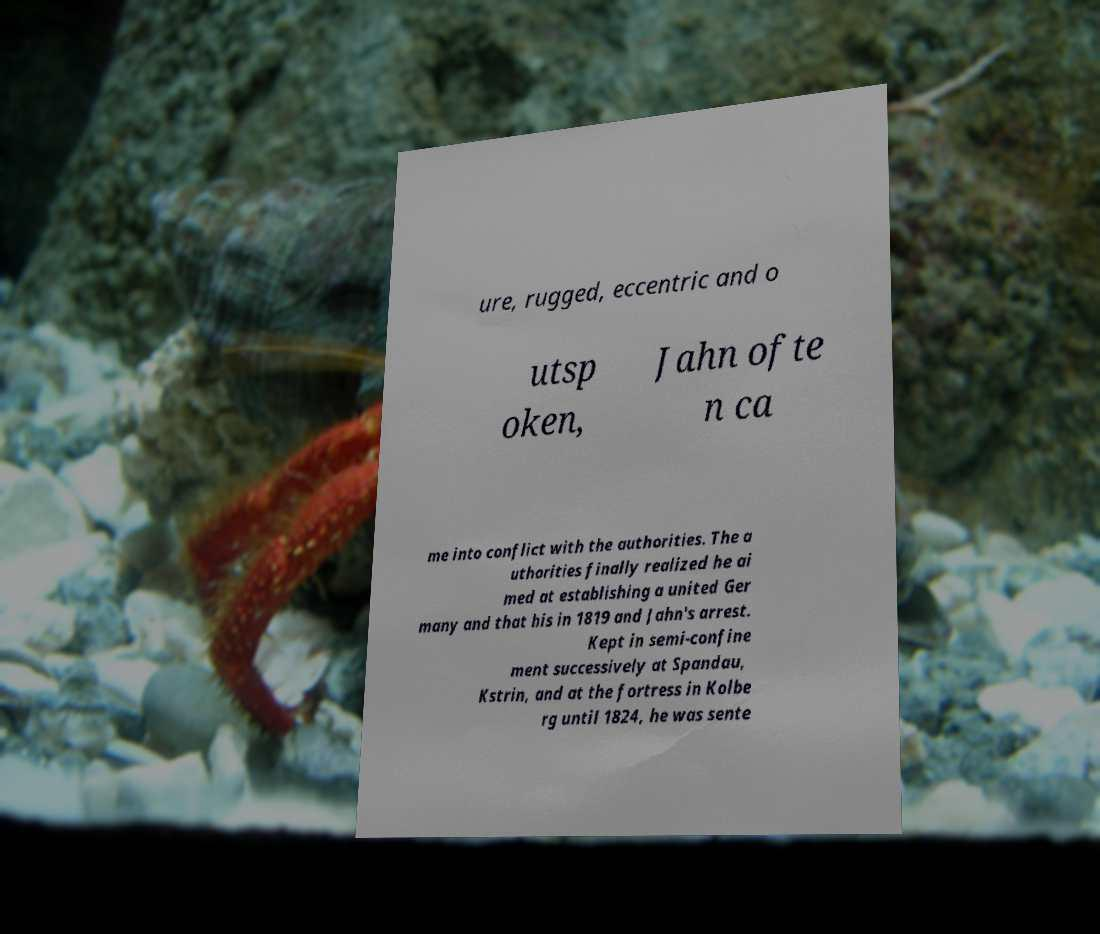Please read and relay the text visible in this image. What does it say? ure, rugged, eccentric and o utsp oken, Jahn ofte n ca me into conflict with the authorities. The a uthorities finally realized he ai med at establishing a united Ger many and that his in 1819 and Jahn's arrest. Kept in semi-confine ment successively at Spandau, Kstrin, and at the fortress in Kolbe rg until 1824, he was sente 